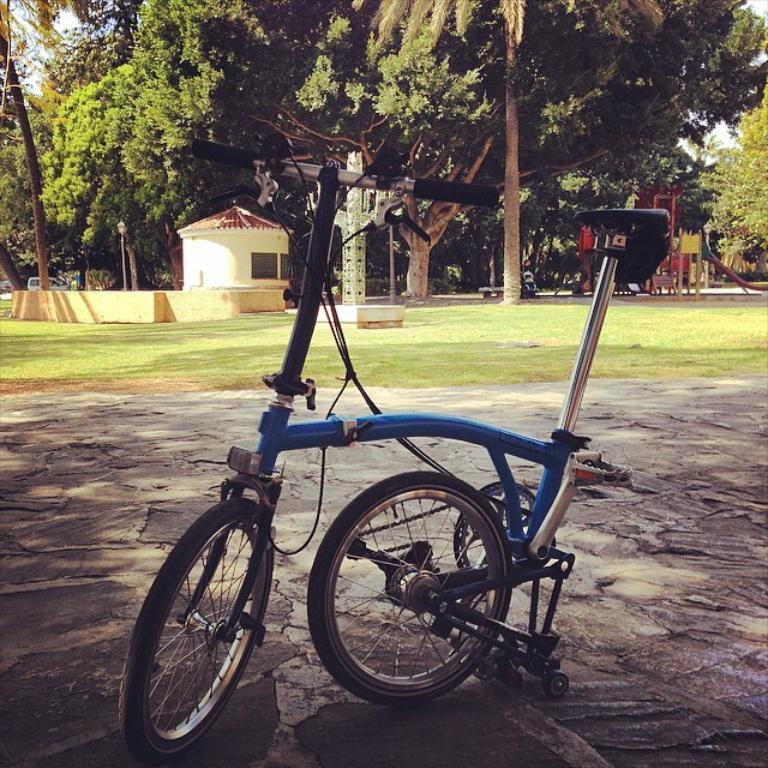What is on the road in the image? There is a bicycle on the road in the image. What can be seen in the background of the image? Sky, trees, motor vehicles, sheds, and a person are visible in the background of the image. Can you describe the natural elements in the background? Trees are present in the background of the image. What type of structures can be seen in the background? Sheds are visible in the background of the image. Can you hear the father whistling in the image? There is no mention of a father or whistling in the image, so it cannot be determined if the father is whistling or not. 